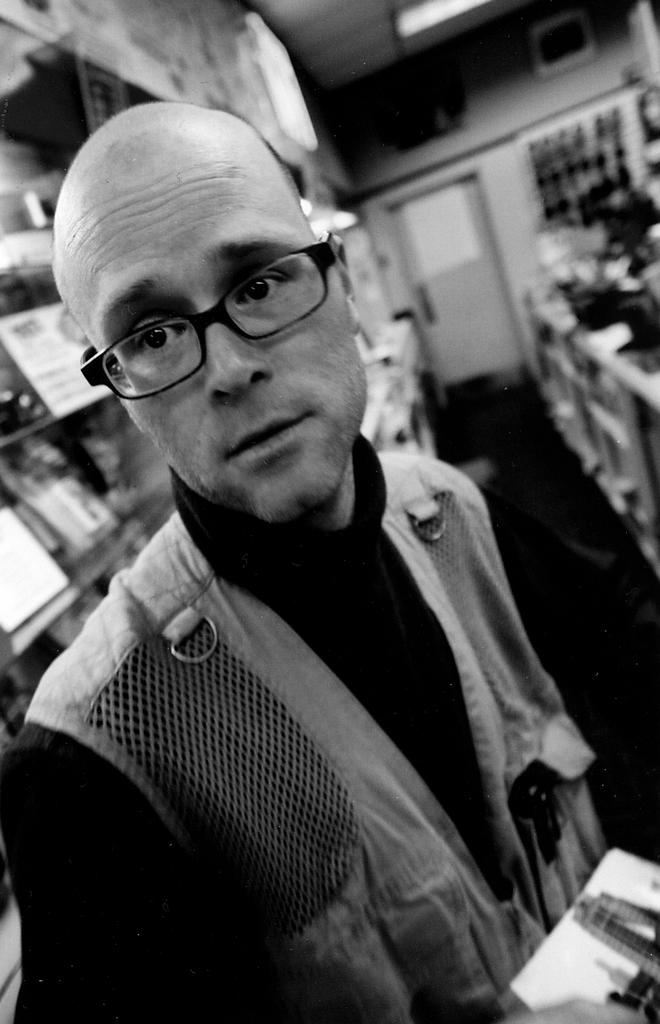What is the main subject of the image? There is a man standing in the image. What is the color scheme of the image? The image is black and white. What can be seen in the background of the image? There are books in a rack and a door visible in the background. How many eyes can be seen on the canvas in the image? There is no canvas present in the image, and therefore no eyes can be seen on it. 